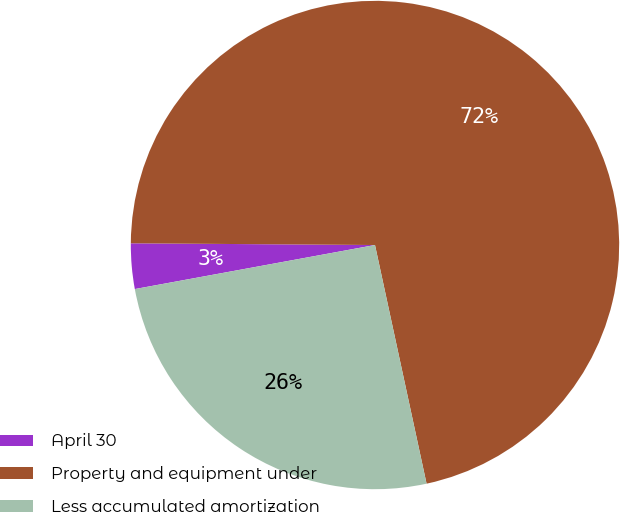Convert chart. <chart><loc_0><loc_0><loc_500><loc_500><pie_chart><fcel>April 30<fcel>Property and equipment under<fcel>Less accumulated amortization<nl><fcel>3.0%<fcel>71.5%<fcel>25.5%<nl></chart> 